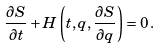Convert formula to latex. <formula><loc_0><loc_0><loc_500><loc_500>\frac { \partial S } { \partial t } + H \left ( t , q , \frac { \partial S } { \partial q } \right ) = 0 \, .</formula> 